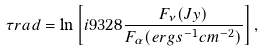<formula> <loc_0><loc_0><loc_500><loc_500>\tau r a d = \ln \left [ i { 9 } { 3 2 } { 8 } \frac { F _ { \nu } ( J y ) } { F _ { \alpha } ( e r g s ^ { - 1 } c m ^ { - 2 } ) } \right ] ,</formula> 